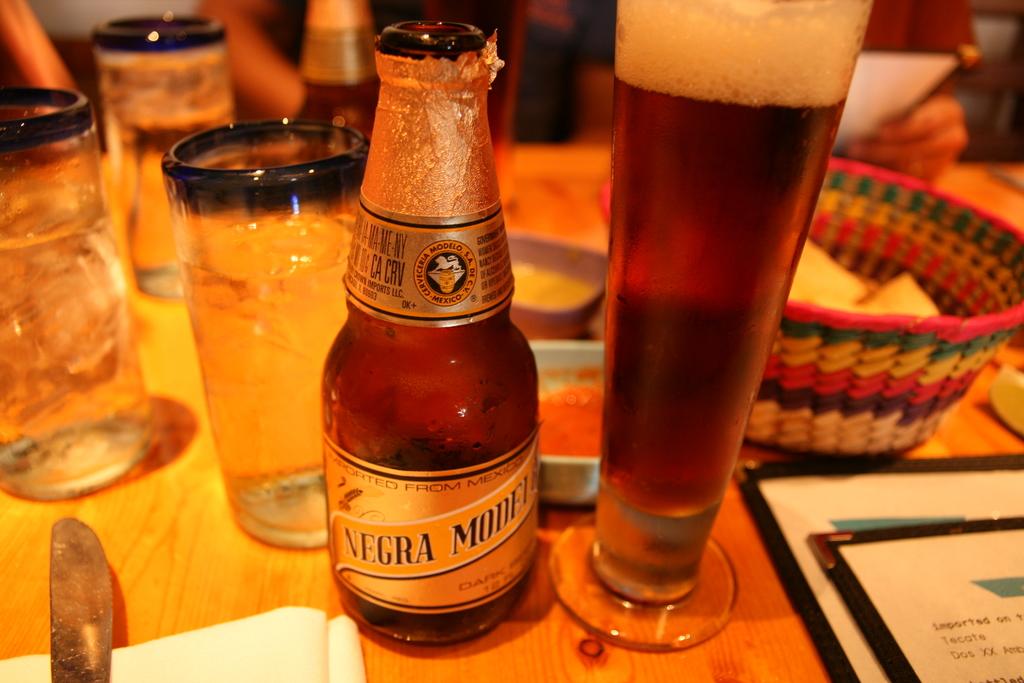What brand os beer is on the table?
Give a very brief answer. Negra modelo. Where was this beer imported from?
Offer a terse response. Mexico. 